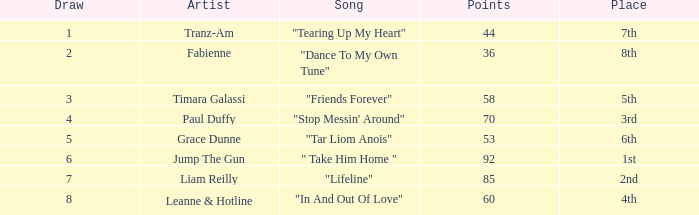With a draw exceeding 5, what is the cumulative point count for grace dunne? 0.0. 